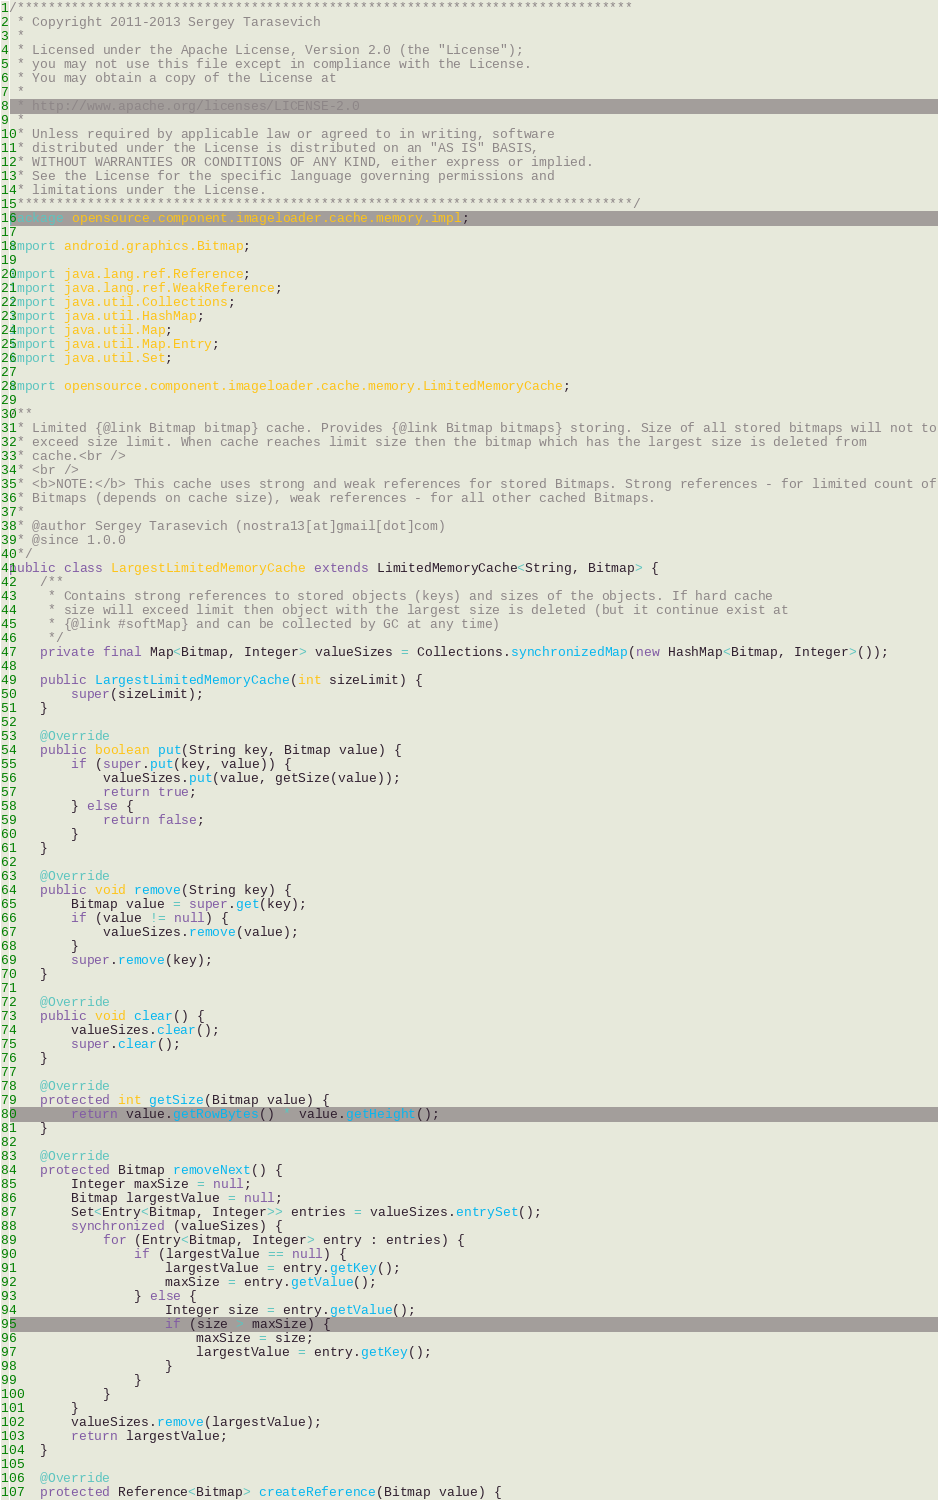<code> <loc_0><loc_0><loc_500><loc_500><_Java_>/*******************************************************************************
 * Copyright 2011-2013 Sergey Tarasevich
 *
 * Licensed under the Apache License, Version 2.0 (the "License");
 * you may not use this file except in compliance with the License.
 * You may obtain a copy of the License at
 *
 * http://www.apache.org/licenses/LICENSE-2.0
 *
 * Unless required by applicable law or agreed to in writing, software
 * distributed under the License is distributed on an "AS IS" BASIS,
 * WITHOUT WARRANTIES OR CONDITIONS OF ANY KIND, either express or implied.
 * See the License for the specific language governing permissions and
 * limitations under the License.
 *******************************************************************************/
package opensource.component.imageloader.cache.memory.impl;

import android.graphics.Bitmap;

import java.lang.ref.Reference;
import java.lang.ref.WeakReference;
import java.util.Collections;
import java.util.HashMap;
import java.util.Map;
import java.util.Map.Entry;
import java.util.Set;

import opensource.component.imageloader.cache.memory.LimitedMemoryCache;

/**
 * Limited {@link Bitmap bitmap} cache. Provides {@link Bitmap bitmaps} storing. Size of all stored bitmaps will not to
 * exceed size limit. When cache reaches limit size then the bitmap which has the largest size is deleted from
 * cache.<br />
 * <br />
 * <b>NOTE:</b> This cache uses strong and weak references for stored Bitmaps. Strong references - for limited count of
 * Bitmaps (depends on cache size), weak references - for all other cached Bitmaps.
 *
 * @author Sergey Tarasevich (nostra13[at]gmail[dot]com)
 * @since 1.0.0
 */
public class LargestLimitedMemoryCache extends LimitedMemoryCache<String, Bitmap> {
	/**
	 * Contains strong references to stored objects (keys) and sizes of the objects. If hard cache
	 * size will exceed limit then object with the largest size is deleted (but it continue exist at
	 * {@link #softMap} and can be collected by GC at any time)
	 */
	private final Map<Bitmap, Integer> valueSizes = Collections.synchronizedMap(new HashMap<Bitmap, Integer>());

	public LargestLimitedMemoryCache(int sizeLimit) {
		super(sizeLimit);
	}

	@Override
	public boolean put(String key, Bitmap value) {
		if (super.put(key, value)) {
			valueSizes.put(value, getSize(value));
			return true;
		} else {
			return false;
		}
	}

	@Override
	public void remove(String key) {
		Bitmap value = super.get(key);
		if (value != null) {
			valueSizes.remove(value);
		}
		super.remove(key);
	}

	@Override
	public void clear() {
		valueSizes.clear();
		super.clear();
	}

	@Override
	protected int getSize(Bitmap value) {
		return value.getRowBytes() * value.getHeight();
	}

	@Override
	protected Bitmap removeNext() {
		Integer maxSize = null;
		Bitmap largestValue = null;
		Set<Entry<Bitmap, Integer>> entries = valueSizes.entrySet();
		synchronized (valueSizes) {
			for (Entry<Bitmap, Integer> entry : entries) {
				if (largestValue == null) {
					largestValue = entry.getKey();
					maxSize = entry.getValue();
				} else {
					Integer size = entry.getValue();
					if (size > maxSize) {
						maxSize = size;
						largestValue = entry.getKey();
					}
				}
			}
		}
		valueSizes.remove(largestValue);
		return largestValue;
	}

	@Override
	protected Reference<Bitmap> createReference(Bitmap value) {</code> 